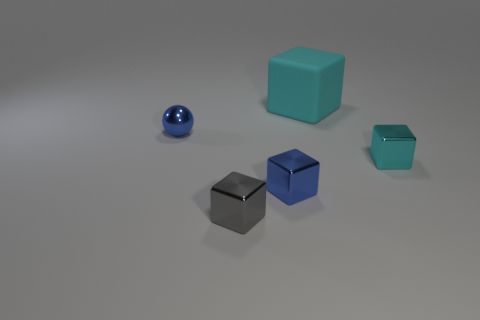Are there more things that are to the right of the metallic sphere than cyan matte things that are on the left side of the gray thing?
Provide a succinct answer. Yes. What color is the metallic object behind the cyan thing that is to the right of the object that is behind the small blue metallic sphere?
Keep it short and to the point. Blue. There is a block that is right of the big cyan block; does it have the same color as the metallic ball?
Your answer should be compact. No. How many other objects are there of the same color as the metallic sphere?
Ensure brevity in your answer.  1. What number of things are either cyan matte objects or small brown metal cylinders?
Offer a very short reply. 1. What number of things are cyan matte objects or tiny shiny objects behind the gray cube?
Keep it short and to the point. 4. Are the tiny gray object and the sphere made of the same material?
Make the answer very short. Yes. What number of other objects are there of the same material as the tiny gray object?
Your answer should be compact. 3. Are there more gray metallic objects than cubes?
Make the answer very short. No. Do the blue object that is to the right of the tiny gray metal cube and the rubber thing have the same shape?
Offer a terse response. Yes. 